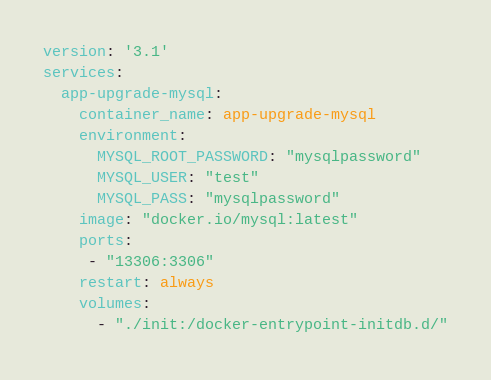Convert code to text. <code><loc_0><loc_0><loc_500><loc_500><_YAML_>version: '3.1'
services:
  app-upgrade-mysql:
    container_name: app-upgrade-mysql
    environment:
      MYSQL_ROOT_PASSWORD: "mysqlpassword"
      MYSQL_USER: "test"
      MYSQL_PASS: "mysqlpassword"
    image: "docker.io/mysql:latest"
    ports:
     - "13306:3306"
    restart: always
    volumes:
      - "./init:/docker-entrypoint-initdb.d/"</code> 